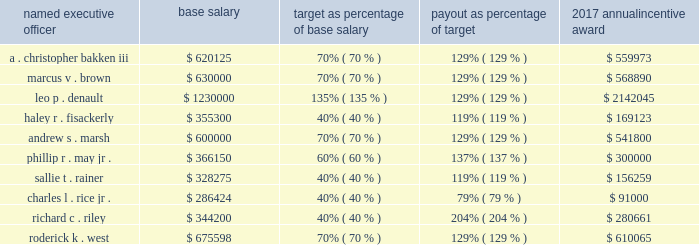Based on the foregoing evaluation of management performance , the personnel committee approved the following annual incentive plan payouts to each named executive officer for 2017 : named executive officer base salary target as percentage of base salary payout as percentage of target 2017 annual incentive award .
Nuclear retention plan mr . a0bakken participates in the nuclear retention plan , a retention plan for officers and other leaders with expertise in the nuclear industry .
The personnel committee authorized this plan to attract and retain key management and employee talent in the nuclear power field , a field that requires unique technical and other expertise that is in great demand in the utility industry .
The plan provides for bonuses to be paid annually over a three-year employment period with the bonus opportunity dependent on the participant 2019s management level and continued employment .
Each annual payment is equal to an amount ranging from 15% ( 15 % ) to 30% ( 30 % ) of the employee 2019s base salary as of their date of enrollment in the plan .
Mr . a0bakken 2019s participation in the plan commenced in may 2016 and in accordance with the terms and conditions of the plan , in may 2017 , 2018 , and 2019 , subject to his continued employment , mr . a0bakken will receive a cash bonus equal to 30% ( 30 % ) of his base salary as of may a01 , 2016 .
This plan does not allow for accelerated or prorated payout upon termination of any kind .
The three-year coverage period and percentage of base salary payable under the plan are consistent with the terms of participation of other senior nuclear officers who participate in this plan .
In may 2017 , mr .
Bakken received a cash bonus of $ 181500 which equaled 30% ( 30 % ) of his may a01 , 2016 , base salary of $ 605000 .
Long-term incentive compensation entergy corporation 2019s goal for its long-term incentive compensation is to focus the executive officers on building shareholder value and to increase the executive officers 2019 ownership of entergy corporation 2019s common stock in order to more closely align their interest with those of entergy corporation 2019s shareholders .
In its long-term incentive compensation programs , entergy corporation uses a mix of performance units , restricted stock , and stock options .
Performance units are used to deliver more than a majority of the total target long-term incentive awards .
For periods through the end of 2017 , performance units reward the named executive officers on the basis of total shareholder return , which is a measure of stock price appreciation and dividend payments , in relation to the companies in the philadelphia utility index .
Beginning with the 2018-2020 performance period , a cumulative utility earnings metric has been added to the long-term performance unit program to supplement the relative total shareholder return measure that historically has been used in this program with each measure equally weighted .
Restricted stock ties the executive officers 2019 long-term financial interest to the long-term financial interests of entergy corporation 2019s shareholders .
Stock options provide a direct incentive to increase the value of entergy corporation 2019s common stock .
In general , entergy corporation seeks to allocate the total value of long-term incentive compensation 60% ( 60 % ) to performance units and 40% ( 40 % ) to a combination of stock options and restricted stock , equally divided in value , based on the value the compensation model seeks to deliver .
Awards for individual named executive officers may vary from this target as a result of individual performance , promotions , and internal pay equity .
The performance units for the 2015-2017 performance period were awarded under the 2011 equity ownership plan and long-term cash incentive plan ( the 201c2011 equity ownership plan 201d ) and the performance units for the .
What is the difference between the highest and the second highest base salary? 
Computations: (1230000 - 675598)
Answer: 554402.0. 